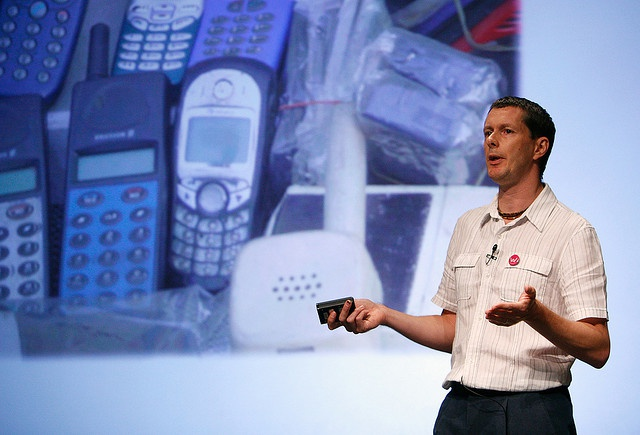Describe the objects in this image and their specific colors. I can see people in navy, lightgray, black, tan, and maroon tones, cell phone in navy, blue, and darkblue tones, cell phone in navy, lightblue, darkgray, blue, and lavender tones, cell phone in navy, blue, and gray tones, and cell phone in navy, darkblue, and blue tones in this image. 